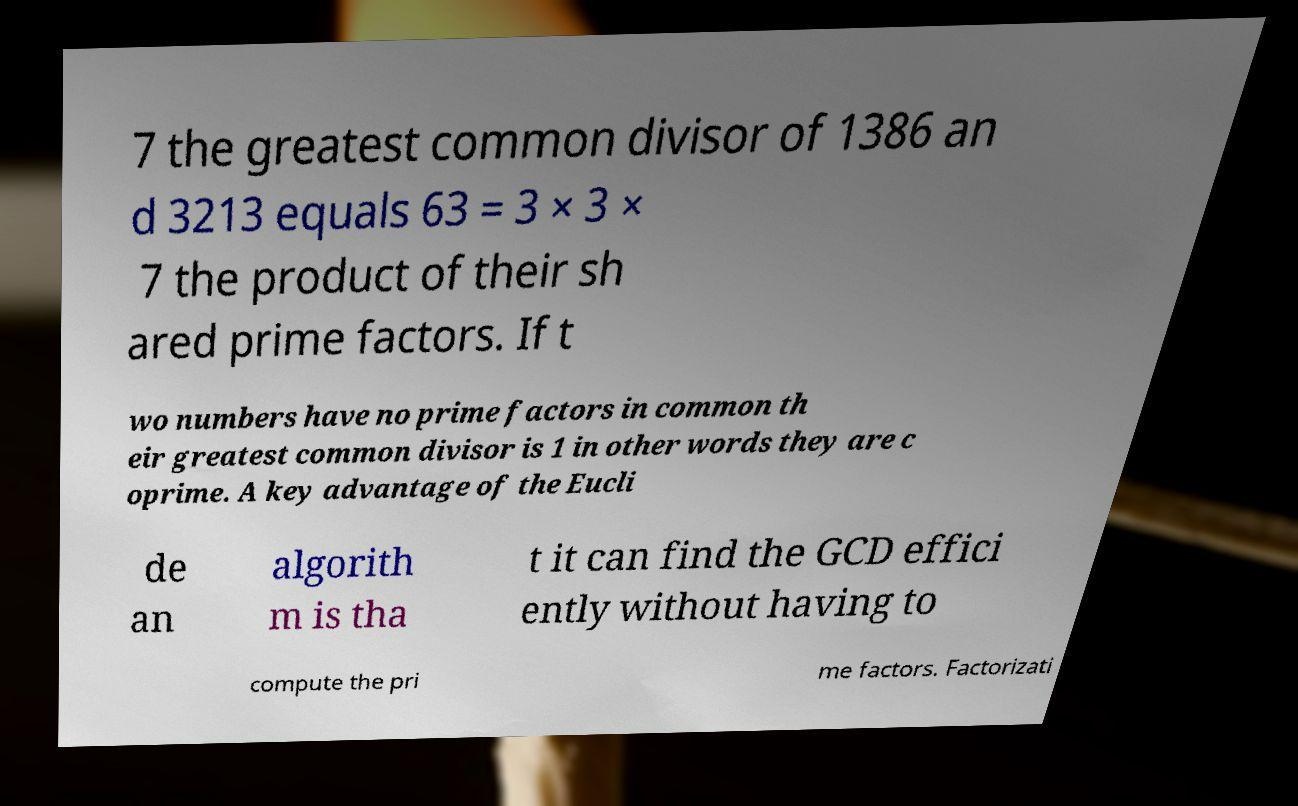There's text embedded in this image that I need extracted. Can you transcribe it verbatim? 7 the greatest common divisor of 1386 an d 3213 equals 63 = 3 × 3 × 7 the product of their sh ared prime factors. If t wo numbers have no prime factors in common th eir greatest common divisor is 1 in other words they are c oprime. A key advantage of the Eucli de an algorith m is tha t it can find the GCD effici ently without having to compute the pri me factors. Factorizati 